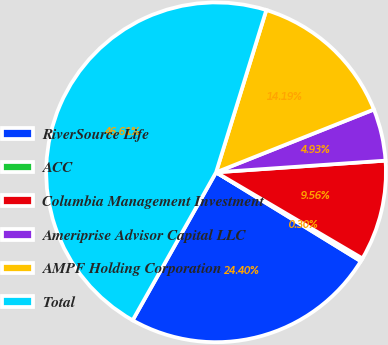Convert chart. <chart><loc_0><loc_0><loc_500><loc_500><pie_chart><fcel>RiverSource Life<fcel>ACC<fcel>Columbia Management Investment<fcel>Ameriprise Advisor Capital LLC<fcel>AMPF Holding Corporation<fcel>Total<nl><fcel>24.4%<fcel>0.3%<fcel>9.56%<fcel>4.93%<fcel>14.19%<fcel>46.6%<nl></chart> 